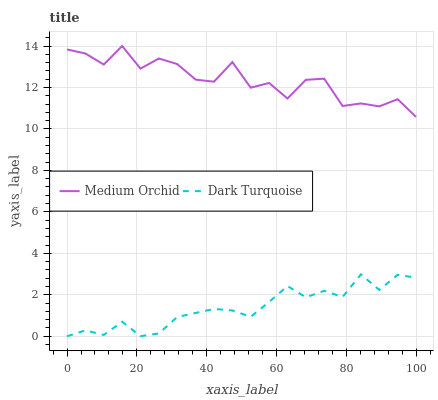Does Medium Orchid have the minimum area under the curve?
Answer yes or no. No. Is Medium Orchid the smoothest?
Answer yes or no. No. Does Medium Orchid have the lowest value?
Answer yes or no. No. Is Dark Turquoise less than Medium Orchid?
Answer yes or no. Yes. Is Medium Orchid greater than Dark Turquoise?
Answer yes or no. Yes. Does Dark Turquoise intersect Medium Orchid?
Answer yes or no. No. 